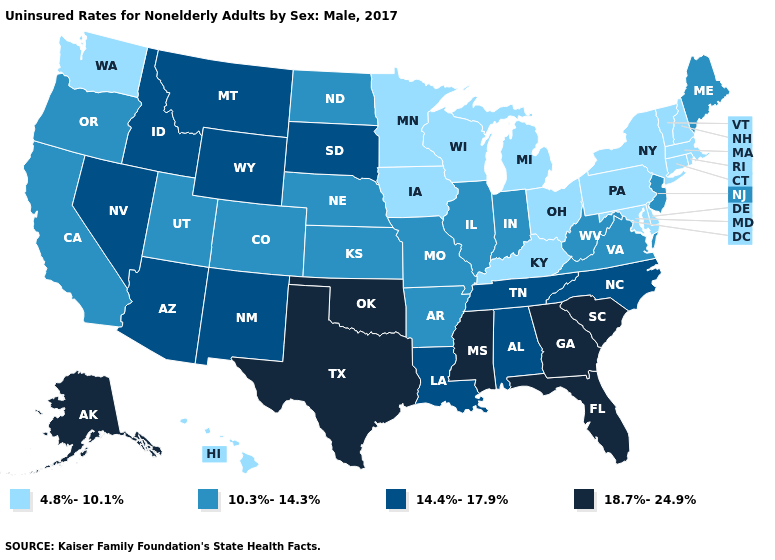Which states have the lowest value in the USA?
Write a very short answer. Connecticut, Delaware, Hawaii, Iowa, Kentucky, Maryland, Massachusetts, Michigan, Minnesota, New Hampshire, New York, Ohio, Pennsylvania, Rhode Island, Vermont, Washington, Wisconsin. Name the states that have a value in the range 14.4%-17.9%?
Concise answer only. Alabama, Arizona, Idaho, Louisiana, Montana, Nevada, New Mexico, North Carolina, South Dakota, Tennessee, Wyoming. Which states have the lowest value in the USA?
Write a very short answer. Connecticut, Delaware, Hawaii, Iowa, Kentucky, Maryland, Massachusetts, Michigan, Minnesota, New Hampshire, New York, Ohio, Pennsylvania, Rhode Island, Vermont, Washington, Wisconsin. What is the value of Mississippi?
Concise answer only. 18.7%-24.9%. What is the lowest value in states that border North Dakota?
Short answer required. 4.8%-10.1%. Name the states that have a value in the range 18.7%-24.9%?
Write a very short answer. Alaska, Florida, Georgia, Mississippi, Oklahoma, South Carolina, Texas. Does Maine have the lowest value in the Northeast?
Give a very brief answer. No. Name the states that have a value in the range 18.7%-24.9%?
Concise answer only. Alaska, Florida, Georgia, Mississippi, Oklahoma, South Carolina, Texas. Name the states that have a value in the range 18.7%-24.9%?
Answer briefly. Alaska, Florida, Georgia, Mississippi, Oklahoma, South Carolina, Texas. Does the first symbol in the legend represent the smallest category?
Write a very short answer. Yes. Name the states that have a value in the range 4.8%-10.1%?
Quick response, please. Connecticut, Delaware, Hawaii, Iowa, Kentucky, Maryland, Massachusetts, Michigan, Minnesota, New Hampshire, New York, Ohio, Pennsylvania, Rhode Island, Vermont, Washington, Wisconsin. Among the states that border Montana , which have the highest value?
Keep it brief. Idaho, South Dakota, Wyoming. Name the states that have a value in the range 10.3%-14.3%?
Quick response, please. Arkansas, California, Colorado, Illinois, Indiana, Kansas, Maine, Missouri, Nebraska, New Jersey, North Dakota, Oregon, Utah, Virginia, West Virginia. Which states hav the highest value in the South?
Be succinct. Florida, Georgia, Mississippi, Oklahoma, South Carolina, Texas. What is the value of Delaware?
Concise answer only. 4.8%-10.1%. 